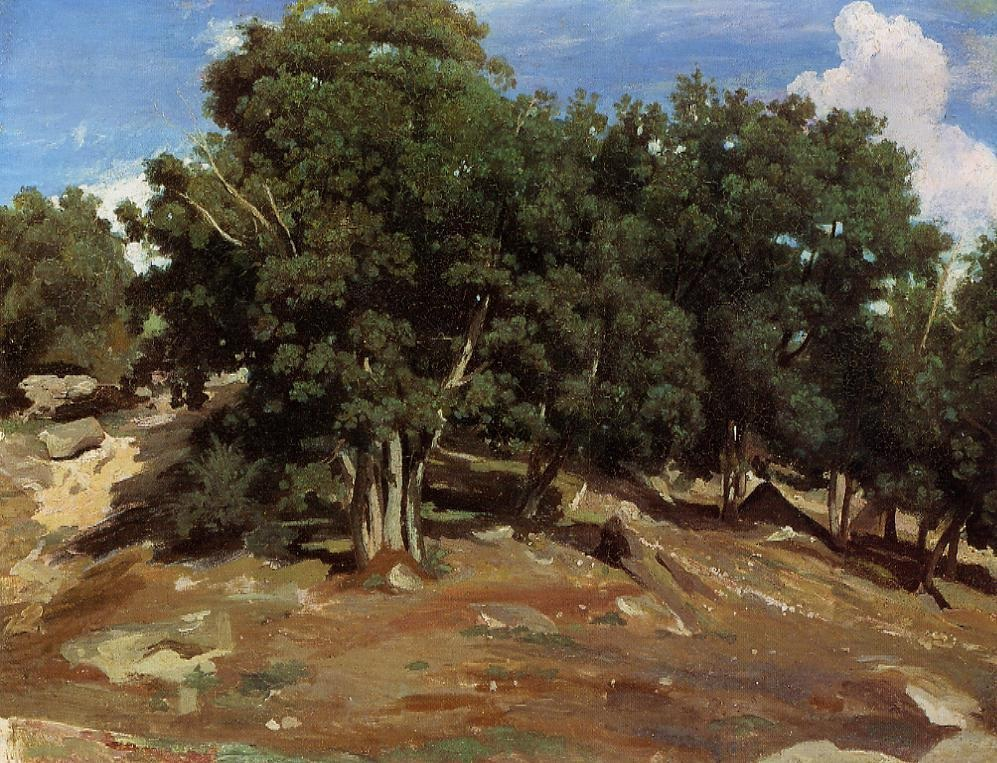Can you describe the mood of this landscape? The mood of this landscape can be described as serene and peaceful. The tall, green trees and the soft texture of the impressionist brushstrokes evoke a sense of calm and tranquility. The rugged hillside, with its mix of rocks and grass, enhances the natural and untouched beauty of the scene, inviting viewers to feel a deep connection with nature. What might be the best time of day to visit a place like this in reality? The best time of day to visit a place like this would likely be early morning or late afternoon. During these times, the light is softer, casting gentle shadows and highlighting the natural beauty of the landscape. The early morning would offer a peaceful atmosphere with the fresh, crisp air, while the late afternoon would provide a warm, golden light that enhances the colors of the trees and rocks, making it an ideal time for reflection and relaxation. Imagine lying under those trees. What sights, sounds, and scents might you experience? Imagine lying under those trees, feeling the soft, cool shade on your skin while looking up to see the sunlight filtering through the leaves, casting delicate, moving patterns on the ground. You might hear the gentle rustling of leaves as the wind whispers through the branches, accompanied by the occasional chirping of birds or the distant sound of a flowing stream. The scent of fresh pine or earth would fill the air, bringing a sense of grounding and connection to the natural world. This sensory experience would create a perfect blend of relaxation and rejuvenation, inviting you to fully immerse yourself in the beauty of the landscape. 